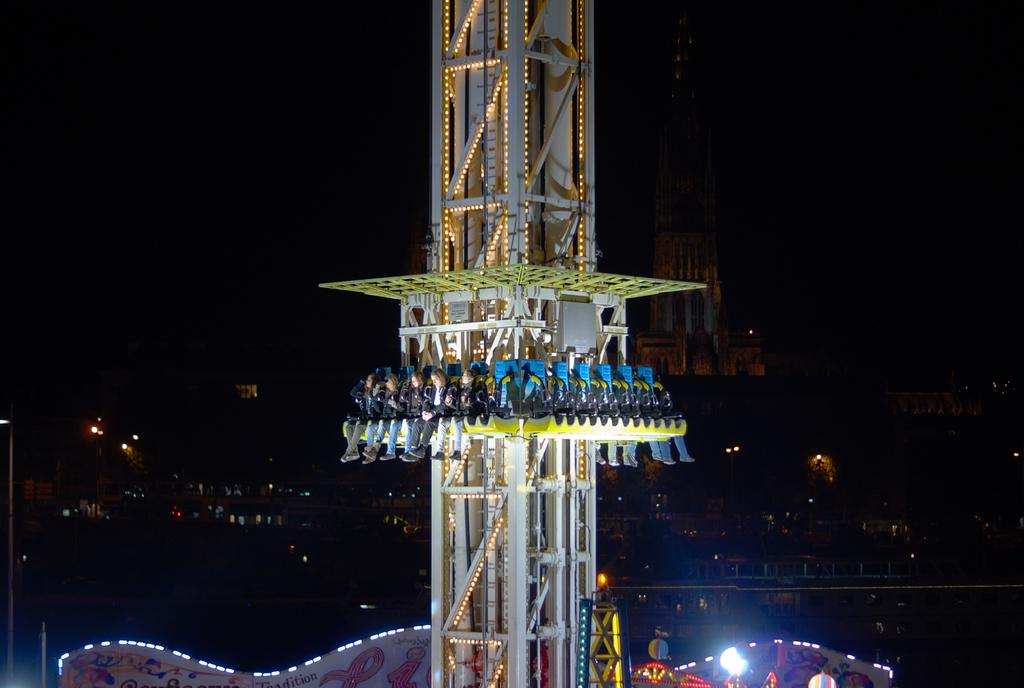What are the people in the image doing? The people in the image are sitting. How are the people arranged in the image? The people are sitting one after the other. What can be seen in the middle of the image? There is a tower in the middle of the image. What type of taste does the farmer experience while sitting in the image? There is no farmer present in the image, and therefore no taste can be associated with the image. 